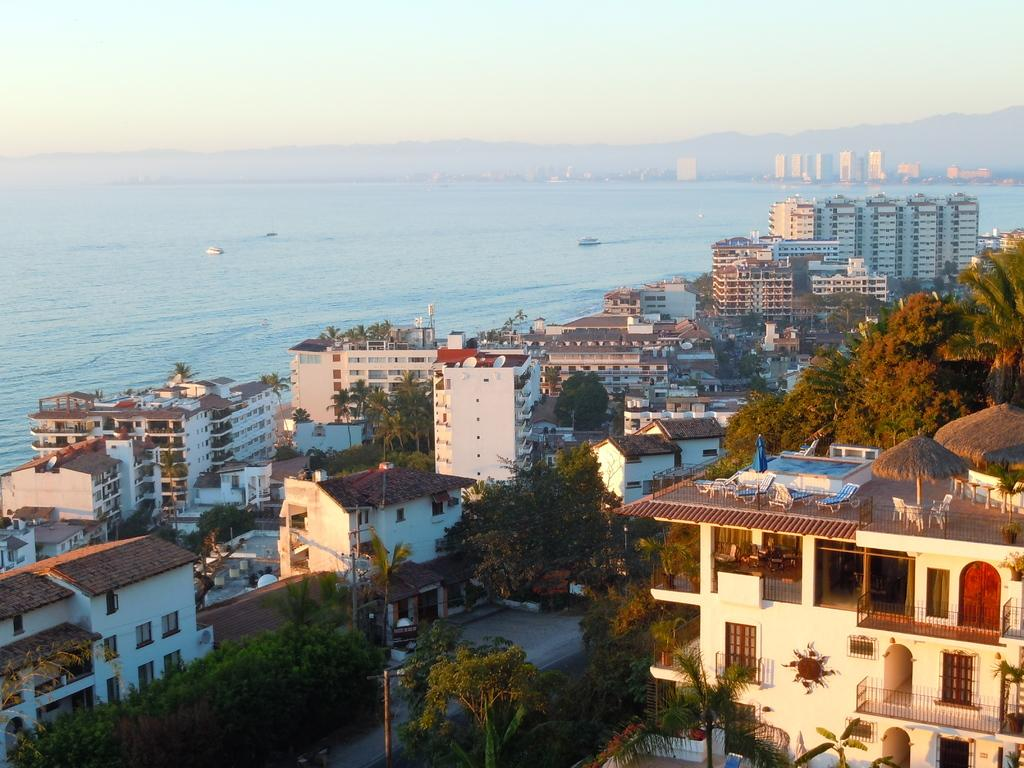What type of view is shown in the image? The image is an aerial view. What type of structures can be seen in the image? There are houses and buildings in the image. What type of natural elements can be seen in the image? There are trees, the sea, and mountains in the image. What part of the natural environment is visible in the image? The sky is visible in the image. What type of cushion is used to decorate the mountains in the image? There is no cushion present in the image, as the mountains are a natural element. 